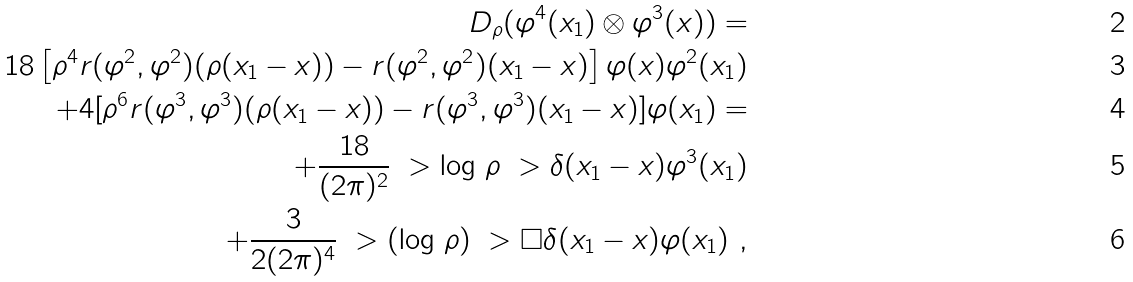<formula> <loc_0><loc_0><loc_500><loc_500>D _ { \rho } ( \varphi ^ { 4 } ( x _ { 1 } ) \otimes \varphi ^ { 3 } ( x ) ) = \\ 1 8 \left [ \rho ^ { 4 } r ( \varphi ^ { 2 } , \varphi ^ { 2 } ) ( \rho ( x _ { 1 } - x ) ) - r ( \varphi ^ { 2 } , \varphi ^ { 2 } ) ( x _ { 1 } - x ) \right ] \varphi ( x ) \varphi ^ { 2 } ( x _ { 1 } ) \\ + 4 [ \rho ^ { 6 } r ( \varphi ^ { 3 } , \varphi ^ { 3 } ) ( \rho ( x _ { 1 } - x ) ) - r ( \varphi ^ { 3 } , \varphi ^ { 3 } ) ( x _ { 1 } - x ) ] \varphi ( x _ { 1 } ) = \\ + \frac { 1 8 } { ( 2 \pi ) ^ { 2 } } \ > \log \, \rho \ > \delta ( x _ { 1 } - x ) \varphi ^ { 3 } ( x _ { 1 } ) \\ + \frac { 3 } { 2 ( 2 \pi ) ^ { 4 } } \ > ( \log \, \rho ) \ > \square \delta ( x _ { 1 } - x ) \varphi ( x _ { 1 } ) \ ,</formula> 